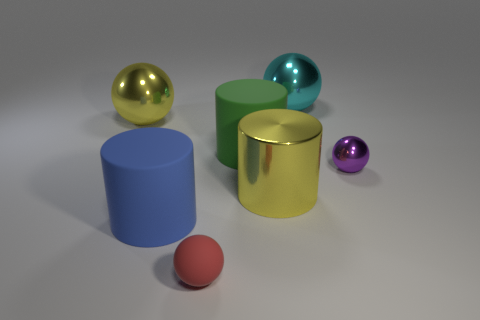Add 3 small red rubber spheres. How many objects exist? 10 Subtract all blue spheres. Subtract all brown cylinders. How many spheres are left? 4 Subtract all cylinders. How many objects are left? 4 Add 6 rubber spheres. How many rubber spheres are left? 7 Add 4 tiny green cylinders. How many tiny green cylinders exist? 4 Subtract 0 green balls. How many objects are left? 7 Subtract all gray balls. Subtract all big objects. How many objects are left? 2 